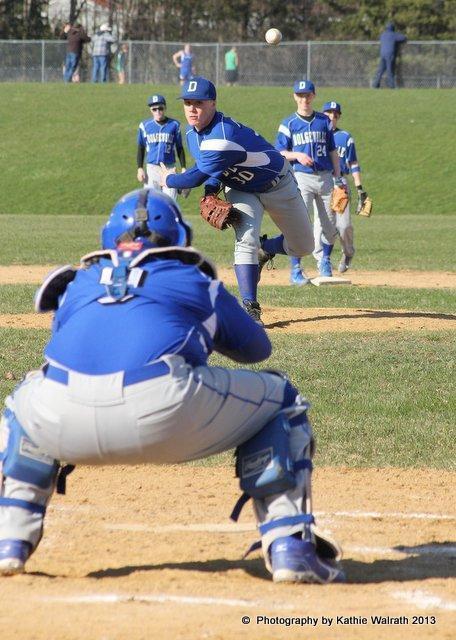What numbered player last touched the ball?
Make your selection and explain in format: 'Answer: answer
Rationale: rationale.'
Options: One, 30, 13, two. Answer: 30.
Rationale: The pitcher will throw the ball to the batter for them to hit it. 